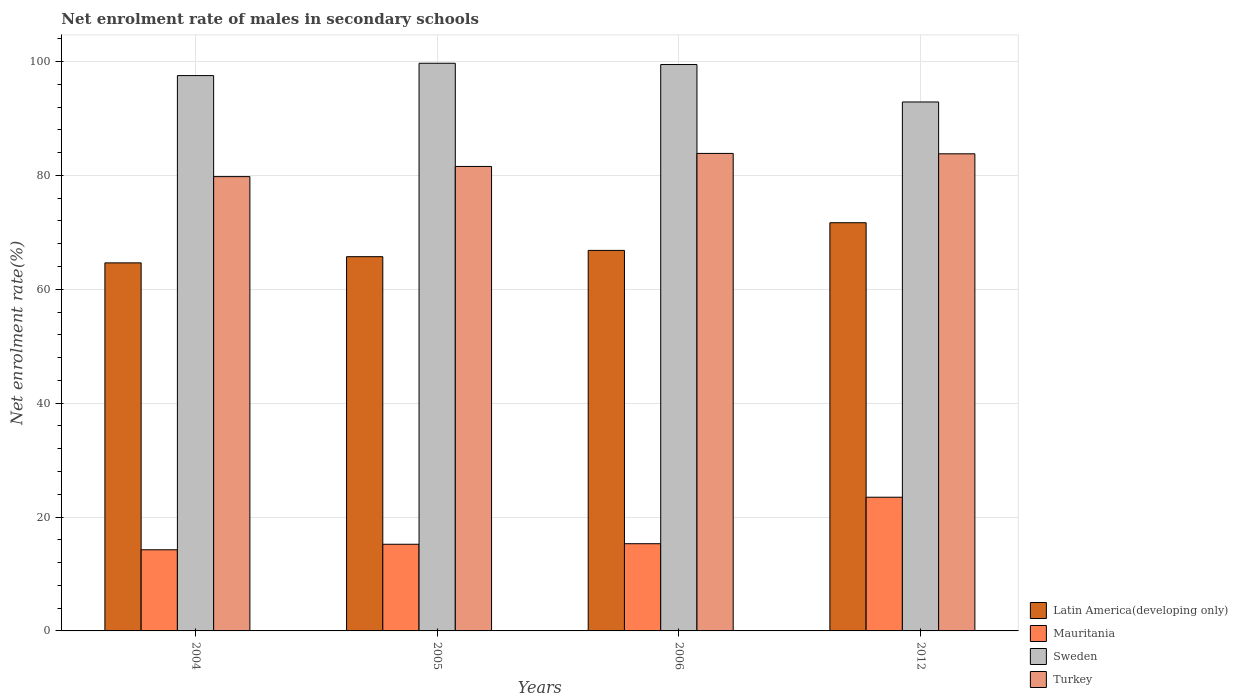Are the number of bars per tick equal to the number of legend labels?
Give a very brief answer. Yes. Are the number of bars on each tick of the X-axis equal?
Keep it short and to the point. Yes. How many bars are there on the 2nd tick from the left?
Your answer should be very brief. 4. How many bars are there on the 3rd tick from the right?
Offer a very short reply. 4. What is the net enrolment rate of males in secondary schools in Latin America(developing only) in 2004?
Make the answer very short. 64.63. Across all years, what is the maximum net enrolment rate of males in secondary schools in Latin America(developing only)?
Provide a succinct answer. 71.68. Across all years, what is the minimum net enrolment rate of males in secondary schools in Sweden?
Provide a short and direct response. 92.88. What is the total net enrolment rate of males in secondary schools in Mauritania in the graph?
Your answer should be very brief. 68.26. What is the difference between the net enrolment rate of males in secondary schools in Turkey in 2004 and that in 2006?
Your answer should be compact. -4.07. What is the difference between the net enrolment rate of males in secondary schools in Mauritania in 2005 and the net enrolment rate of males in secondary schools in Latin America(developing only) in 2004?
Keep it short and to the point. -49.41. What is the average net enrolment rate of males in secondary schools in Turkey per year?
Your response must be concise. 82.24. In the year 2004, what is the difference between the net enrolment rate of males in secondary schools in Turkey and net enrolment rate of males in secondary schools in Latin America(developing only)?
Your answer should be very brief. 15.15. In how many years, is the net enrolment rate of males in secondary schools in Latin America(developing only) greater than 36 %?
Give a very brief answer. 4. What is the ratio of the net enrolment rate of males in secondary schools in Latin America(developing only) in 2006 to that in 2012?
Your answer should be compact. 0.93. Is the net enrolment rate of males in secondary schools in Latin America(developing only) in 2004 less than that in 2012?
Offer a very short reply. Yes. Is the difference between the net enrolment rate of males in secondary schools in Turkey in 2006 and 2012 greater than the difference between the net enrolment rate of males in secondary schools in Latin America(developing only) in 2006 and 2012?
Keep it short and to the point. Yes. What is the difference between the highest and the second highest net enrolment rate of males in secondary schools in Turkey?
Keep it short and to the point. 0.07. What is the difference between the highest and the lowest net enrolment rate of males in secondary schools in Sweden?
Your answer should be very brief. 6.8. In how many years, is the net enrolment rate of males in secondary schools in Sweden greater than the average net enrolment rate of males in secondary schools in Sweden taken over all years?
Your answer should be compact. 3. Is it the case that in every year, the sum of the net enrolment rate of males in secondary schools in Turkey and net enrolment rate of males in secondary schools in Sweden is greater than the sum of net enrolment rate of males in secondary schools in Latin America(developing only) and net enrolment rate of males in secondary schools in Mauritania?
Ensure brevity in your answer.  Yes. What does the 1st bar from the right in 2006 represents?
Give a very brief answer. Turkey. Is it the case that in every year, the sum of the net enrolment rate of males in secondary schools in Turkey and net enrolment rate of males in secondary schools in Latin America(developing only) is greater than the net enrolment rate of males in secondary schools in Sweden?
Your response must be concise. Yes. How many bars are there?
Your answer should be very brief. 16. How many years are there in the graph?
Make the answer very short. 4. Does the graph contain any zero values?
Keep it short and to the point. No. Does the graph contain grids?
Offer a terse response. Yes. How are the legend labels stacked?
Offer a terse response. Vertical. What is the title of the graph?
Keep it short and to the point. Net enrolment rate of males in secondary schools. What is the label or title of the X-axis?
Offer a terse response. Years. What is the label or title of the Y-axis?
Provide a short and direct response. Net enrolment rate(%). What is the Net enrolment rate(%) in Latin America(developing only) in 2004?
Your answer should be compact. 64.63. What is the Net enrolment rate(%) of Mauritania in 2004?
Your response must be concise. 14.25. What is the Net enrolment rate(%) in Sweden in 2004?
Your response must be concise. 97.52. What is the Net enrolment rate(%) of Turkey in 2004?
Offer a terse response. 79.78. What is the Net enrolment rate(%) in Latin America(developing only) in 2005?
Make the answer very short. 65.72. What is the Net enrolment rate(%) in Mauritania in 2005?
Make the answer very short. 15.22. What is the Net enrolment rate(%) in Sweden in 2005?
Make the answer very short. 99.68. What is the Net enrolment rate(%) in Turkey in 2005?
Your response must be concise. 81.56. What is the Net enrolment rate(%) of Latin America(developing only) in 2006?
Give a very brief answer. 66.82. What is the Net enrolment rate(%) in Mauritania in 2006?
Make the answer very short. 15.31. What is the Net enrolment rate(%) in Sweden in 2006?
Keep it short and to the point. 99.46. What is the Net enrolment rate(%) of Turkey in 2006?
Provide a succinct answer. 83.85. What is the Net enrolment rate(%) in Latin America(developing only) in 2012?
Provide a short and direct response. 71.68. What is the Net enrolment rate(%) in Mauritania in 2012?
Provide a succinct answer. 23.48. What is the Net enrolment rate(%) of Sweden in 2012?
Provide a short and direct response. 92.88. What is the Net enrolment rate(%) in Turkey in 2012?
Your answer should be compact. 83.78. Across all years, what is the maximum Net enrolment rate(%) of Latin America(developing only)?
Provide a short and direct response. 71.68. Across all years, what is the maximum Net enrolment rate(%) of Mauritania?
Provide a short and direct response. 23.48. Across all years, what is the maximum Net enrolment rate(%) in Sweden?
Make the answer very short. 99.68. Across all years, what is the maximum Net enrolment rate(%) of Turkey?
Provide a short and direct response. 83.85. Across all years, what is the minimum Net enrolment rate(%) in Latin America(developing only)?
Your answer should be compact. 64.63. Across all years, what is the minimum Net enrolment rate(%) in Mauritania?
Give a very brief answer. 14.25. Across all years, what is the minimum Net enrolment rate(%) of Sweden?
Make the answer very short. 92.88. Across all years, what is the minimum Net enrolment rate(%) of Turkey?
Offer a very short reply. 79.78. What is the total Net enrolment rate(%) of Latin America(developing only) in the graph?
Offer a terse response. 268.85. What is the total Net enrolment rate(%) of Mauritania in the graph?
Make the answer very short. 68.26. What is the total Net enrolment rate(%) in Sweden in the graph?
Offer a terse response. 389.54. What is the total Net enrolment rate(%) of Turkey in the graph?
Make the answer very short. 328.97. What is the difference between the Net enrolment rate(%) of Latin America(developing only) in 2004 and that in 2005?
Provide a short and direct response. -1.09. What is the difference between the Net enrolment rate(%) of Mauritania in 2004 and that in 2005?
Your answer should be compact. -0.97. What is the difference between the Net enrolment rate(%) of Sweden in 2004 and that in 2005?
Your answer should be very brief. -2.16. What is the difference between the Net enrolment rate(%) of Turkey in 2004 and that in 2005?
Give a very brief answer. -1.78. What is the difference between the Net enrolment rate(%) in Latin America(developing only) in 2004 and that in 2006?
Keep it short and to the point. -2.19. What is the difference between the Net enrolment rate(%) of Mauritania in 2004 and that in 2006?
Make the answer very short. -1.07. What is the difference between the Net enrolment rate(%) in Sweden in 2004 and that in 2006?
Your answer should be very brief. -1.94. What is the difference between the Net enrolment rate(%) of Turkey in 2004 and that in 2006?
Offer a very short reply. -4.07. What is the difference between the Net enrolment rate(%) of Latin America(developing only) in 2004 and that in 2012?
Keep it short and to the point. -7.05. What is the difference between the Net enrolment rate(%) of Mauritania in 2004 and that in 2012?
Your answer should be very brief. -9.23. What is the difference between the Net enrolment rate(%) in Sweden in 2004 and that in 2012?
Your response must be concise. 4.63. What is the difference between the Net enrolment rate(%) in Turkey in 2004 and that in 2012?
Your answer should be compact. -4. What is the difference between the Net enrolment rate(%) of Latin America(developing only) in 2005 and that in 2006?
Make the answer very short. -1.1. What is the difference between the Net enrolment rate(%) of Mauritania in 2005 and that in 2006?
Offer a terse response. -0.1. What is the difference between the Net enrolment rate(%) of Sweden in 2005 and that in 2006?
Provide a short and direct response. 0.23. What is the difference between the Net enrolment rate(%) in Turkey in 2005 and that in 2006?
Your answer should be very brief. -2.29. What is the difference between the Net enrolment rate(%) in Latin America(developing only) in 2005 and that in 2012?
Provide a short and direct response. -5.96. What is the difference between the Net enrolment rate(%) in Mauritania in 2005 and that in 2012?
Provide a short and direct response. -8.26. What is the difference between the Net enrolment rate(%) of Sweden in 2005 and that in 2012?
Offer a terse response. 6.8. What is the difference between the Net enrolment rate(%) in Turkey in 2005 and that in 2012?
Give a very brief answer. -2.22. What is the difference between the Net enrolment rate(%) of Latin America(developing only) in 2006 and that in 2012?
Your response must be concise. -4.86. What is the difference between the Net enrolment rate(%) in Mauritania in 2006 and that in 2012?
Provide a succinct answer. -8.16. What is the difference between the Net enrolment rate(%) of Sweden in 2006 and that in 2012?
Your answer should be very brief. 6.57. What is the difference between the Net enrolment rate(%) of Turkey in 2006 and that in 2012?
Give a very brief answer. 0.07. What is the difference between the Net enrolment rate(%) in Latin America(developing only) in 2004 and the Net enrolment rate(%) in Mauritania in 2005?
Your answer should be compact. 49.41. What is the difference between the Net enrolment rate(%) in Latin America(developing only) in 2004 and the Net enrolment rate(%) in Sweden in 2005?
Keep it short and to the point. -35.05. What is the difference between the Net enrolment rate(%) of Latin America(developing only) in 2004 and the Net enrolment rate(%) of Turkey in 2005?
Your answer should be very brief. -16.93. What is the difference between the Net enrolment rate(%) of Mauritania in 2004 and the Net enrolment rate(%) of Sweden in 2005?
Your answer should be very brief. -85.44. What is the difference between the Net enrolment rate(%) in Mauritania in 2004 and the Net enrolment rate(%) in Turkey in 2005?
Your answer should be compact. -67.31. What is the difference between the Net enrolment rate(%) of Sweden in 2004 and the Net enrolment rate(%) of Turkey in 2005?
Provide a succinct answer. 15.96. What is the difference between the Net enrolment rate(%) in Latin America(developing only) in 2004 and the Net enrolment rate(%) in Mauritania in 2006?
Make the answer very short. 49.32. What is the difference between the Net enrolment rate(%) in Latin America(developing only) in 2004 and the Net enrolment rate(%) in Sweden in 2006?
Your answer should be compact. -34.83. What is the difference between the Net enrolment rate(%) of Latin America(developing only) in 2004 and the Net enrolment rate(%) of Turkey in 2006?
Offer a terse response. -19.22. What is the difference between the Net enrolment rate(%) of Mauritania in 2004 and the Net enrolment rate(%) of Sweden in 2006?
Offer a very short reply. -85.21. What is the difference between the Net enrolment rate(%) of Mauritania in 2004 and the Net enrolment rate(%) of Turkey in 2006?
Offer a terse response. -69.6. What is the difference between the Net enrolment rate(%) of Sweden in 2004 and the Net enrolment rate(%) of Turkey in 2006?
Your answer should be compact. 13.67. What is the difference between the Net enrolment rate(%) of Latin America(developing only) in 2004 and the Net enrolment rate(%) of Mauritania in 2012?
Your answer should be compact. 41.15. What is the difference between the Net enrolment rate(%) in Latin America(developing only) in 2004 and the Net enrolment rate(%) in Sweden in 2012?
Provide a short and direct response. -28.25. What is the difference between the Net enrolment rate(%) of Latin America(developing only) in 2004 and the Net enrolment rate(%) of Turkey in 2012?
Ensure brevity in your answer.  -19.15. What is the difference between the Net enrolment rate(%) of Mauritania in 2004 and the Net enrolment rate(%) of Sweden in 2012?
Your answer should be compact. -78.64. What is the difference between the Net enrolment rate(%) of Mauritania in 2004 and the Net enrolment rate(%) of Turkey in 2012?
Offer a terse response. -69.54. What is the difference between the Net enrolment rate(%) of Sweden in 2004 and the Net enrolment rate(%) of Turkey in 2012?
Your response must be concise. 13.74. What is the difference between the Net enrolment rate(%) of Latin America(developing only) in 2005 and the Net enrolment rate(%) of Mauritania in 2006?
Your answer should be compact. 50.4. What is the difference between the Net enrolment rate(%) in Latin America(developing only) in 2005 and the Net enrolment rate(%) in Sweden in 2006?
Make the answer very short. -33.74. What is the difference between the Net enrolment rate(%) in Latin America(developing only) in 2005 and the Net enrolment rate(%) in Turkey in 2006?
Your response must be concise. -18.13. What is the difference between the Net enrolment rate(%) of Mauritania in 2005 and the Net enrolment rate(%) of Sweden in 2006?
Your answer should be very brief. -84.24. What is the difference between the Net enrolment rate(%) in Mauritania in 2005 and the Net enrolment rate(%) in Turkey in 2006?
Make the answer very short. -68.63. What is the difference between the Net enrolment rate(%) in Sweden in 2005 and the Net enrolment rate(%) in Turkey in 2006?
Provide a short and direct response. 15.83. What is the difference between the Net enrolment rate(%) in Latin America(developing only) in 2005 and the Net enrolment rate(%) in Mauritania in 2012?
Your answer should be very brief. 42.24. What is the difference between the Net enrolment rate(%) of Latin America(developing only) in 2005 and the Net enrolment rate(%) of Sweden in 2012?
Provide a succinct answer. -27.17. What is the difference between the Net enrolment rate(%) of Latin America(developing only) in 2005 and the Net enrolment rate(%) of Turkey in 2012?
Give a very brief answer. -18.06. What is the difference between the Net enrolment rate(%) in Mauritania in 2005 and the Net enrolment rate(%) in Sweden in 2012?
Your answer should be very brief. -77.66. What is the difference between the Net enrolment rate(%) in Mauritania in 2005 and the Net enrolment rate(%) in Turkey in 2012?
Your answer should be compact. -68.56. What is the difference between the Net enrolment rate(%) of Sweden in 2005 and the Net enrolment rate(%) of Turkey in 2012?
Keep it short and to the point. 15.9. What is the difference between the Net enrolment rate(%) of Latin America(developing only) in 2006 and the Net enrolment rate(%) of Mauritania in 2012?
Keep it short and to the point. 43.34. What is the difference between the Net enrolment rate(%) of Latin America(developing only) in 2006 and the Net enrolment rate(%) of Sweden in 2012?
Keep it short and to the point. -26.06. What is the difference between the Net enrolment rate(%) of Latin America(developing only) in 2006 and the Net enrolment rate(%) of Turkey in 2012?
Provide a short and direct response. -16.96. What is the difference between the Net enrolment rate(%) of Mauritania in 2006 and the Net enrolment rate(%) of Sweden in 2012?
Ensure brevity in your answer.  -77.57. What is the difference between the Net enrolment rate(%) in Mauritania in 2006 and the Net enrolment rate(%) in Turkey in 2012?
Your answer should be compact. -68.47. What is the difference between the Net enrolment rate(%) of Sweden in 2006 and the Net enrolment rate(%) of Turkey in 2012?
Offer a very short reply. 15.67. What is the average Net enrolment rate(%) in Latin America(developing only) per year?
Your answer should be very brief. 67.21. What is the average Net enrolment rate(%) in Mauritania per year?
Give a very brief answer. 17.06. What is the average Net enrolment rate(%) in Sweden per year?
Offer a terse response. 97.38. What is the average Net enrolment rate(%) of Turkey per year?
Provide a short and direct response. 82.24. In the year 2004, what is the difference between the Net enrolment rate(%) of Latin America(developing only) and Net enrolment rate(%) of Mauritania?
Ensure brevity in your answer.  50.38. In the year 2004, what is the difference between the Net enrolment rate(%) of Latin America(developing only) and Net enrolment rate(%) of Sweden?
Offer a very short reply. -32.89. In the year 2004, what is the difference between the Net enrolment rate(%) in Latin America(developing only) and Net enrolment rate(%) in Turkey?
Your answer should be very brief. -15.15. In the year 2004, what is the difference between the Net enrolment rate(%) of Mauritania and Net enrolment rate(%) of Sweden?
Your answer should be compact. -83.27. In the year 2004, what is the difference between the Net enrolment rate(%) in Mauritania and Net enrolment rate(%) in Turkey?
Your answer should be compact. -65.53. In the year 2004, what is the difference between the Net enrolment rate(%) of Sweden and Net enrolment rate(%) of Turkey?
Make the answer very short. 17.74. In the year 2005, what is the difference between the Net enrolment rate(%) of Latin America(developing only) and Net enrolment rate(%) of Mauritania?
Make the answer very short. 50.5. In the year 2005, what is the difference between the Net enrolment rate(%) in Latin America(developing only) and Net enrolment rate(%) in Sweden?
Provide a succinct answer. -33.96. In the year 2005, what is the difference between the Net enrolment rate(%) in Latin America(developing only) and Net enrolment rate(%) in Turkey?
Your response must be concise. -15.84. In the year 2005, what is the difference between the Net enrolment rate(%) in Mauritania and Net enrolment rate(%) in Sweden?
Your response must be concise. -84.46. In the year 2005, what is the difference between the Net enrolment rate(%) in Mauritania and Net enrolment rate(%) in Turkey?
Provide a succinct answer. -66.34. In the year 2005, what is the difference between the Net enrolment rate(%) of Sweden and Net enrolment rate(%) of Turkey?
Keep it short and to the point. 18.12. In the year 2006, what is the difference between the Net enrolment rate(%) in Latin America(developing only) and Net enrolment rate(%) in Mauritania?
Ensure brevity in your answer.  51.5. In the year 2006, what is the difference between the Net enrolment rate(%) of Latin America(developing only) and Net enrolment rate(%) of Sweden?
Your answer should be compact. -32.64. In the year 2006, what is the difference between the Net enrolment rate(%) in Latin America(developing only) and Net enrolment rate(%) in Turkey?
Offer a very short reply. -17.03. In the year 2006, what is the difference between the Net enrolment rate(%) of Mauritania and Net enrolment rate(%) of Sweden?
Provide a short and direct response. -84.14. In the year 2006, what is the difference between the Net enrolment rate(%) of Mauritania and Net enrolment rate(%) of Turkey?
Your answer should be compact. -68.54. In the year 2006, what is the difference between the Net enrolment rate(%) of Sweden and Net enrolment rate(%) of Turkey?
Your answer should be compact. 15.6. In the year 2012, what is the difference between the Net enrolment rate(%) of Latin America(developing only) and Net enrolment rate(%) of Mauritania?
Offer a terse response. 48.2. In the year 2012, what is the difference between the Net enrolment rate(%) in Latin America(developing only) and Net enrolment rate(%) in Sweden?
Offer a terse response. -21.21. In the year 2012, what is the difference between the Net enrolment rate(%) of Latin America(developing only) and Net enrolment rate(%) of Turkey?
Your answer should be compact. -12.1. In the year 2012, what is the difference between the Net enrolment rate(%) in Mauritania and Net enrolment rate(%) in Sweden?
Offer a very short reply. -69.41. In the year 2012, what is the difference between the Net enrolment rate(%) in Mauritania and Net enrolment rate(%) in Turkey?
Your response must be concise. -60.31. In the year 2012, what is the difference between the Net enrolment rate(%) in Sweden and Net enrolment rate(%) in Turkey?
Offer a very short reply. 9.1. What is the ratio of the Net enrolment rate(%) in Latin America(developing only) in 2004 to that in 2005?
Your answer should be very brief. 0.98. What is the ratio of the Net enrolment rate(%) of Mauritania in 2004 to that in 2005?
Make the answer very short. 0.94. What is the ratio of the Net enrolment rate(%) in Sweden in 2004 to that in 2005?
Keep it short and to the point. 0.98. What is the ratio of the Net enrolment rate(%) in Turkey in 2004 to that in 2005?
Offer a very short reply. 0.98. What is the ratio of the Net enrolment rate(%) in Latin America(developing only) in 2004 to that in 2006?
Make the answer very short. 0.97. What is the ratio of the Net enrolment rate(%) in Mauritania in 2004 to that in 2006?
Keep it short and to the point. 0.93. What is the ratio of the Net enrolment rate(%) of Sweden in 2004 to that in 2006?
Give a very brief answer. 0.98. What is the ratio of the Net enrolment rate(%) in Turkey in 2004 to that in 2006?
Keep it short and to the point. 0.95. What is the ratio of the Net enrolment rate(%) in Latin America(developing only) in 2004 to that in 2012?
Make the answer very short. 0.9. What is the ratio of the Net enrolment rate(%) of Mauritania in 2004 to that in 2012?
Keep it short and to the point. 0.61. What is the ratio of the Net enrolment rate(%) of Sweden in 2004 to that in 2012?
Offer a terse response. 1.05. What is the ratio of the Net enrolment rate(%) of Turkey in 2004 to that in 2012?
Your answer should be compact. 0.95. What is the ratio of the Net enrolment rate(%) in Latin America(developing only) in 2005 to that in 2006?
Give a very brief answer. 0.98. What is the ratio of the Net enrolment rate(%) in Turkey in 2005 to that in 2006?
Your response must be concise. 0.97. What is the ratio of the Net enrolment rate(%) in Latin America(developing only) in 2005 to that in 2012?
Keep it short and to the point. 0.92. What is the ratio of the Net enrolment rate(%) of Mauritania in 2005 to that in 2012?
Offer a terse response. 0.65. What is the ratio of the Net enrolment rate(%) in Sweden in 2005 to that in 2012?
Your answer should be very brief. 1.07. What is the ratio of the Net enrolment rate(%) of Turkey in 2005 to that in 2012?
Your answer should be compact. 0.97. What is the ratio of the Net enrolment rate(%) in Latin America(developing only) in 2006 to that in 2012?
Offer a very short reply. 0.93. What is the ratio of the Net enrolment rate(%) in Mauritania in 2006 to that in 2012?
Your response must be concise. 0.65. What is the ratio of the Net enrolment rate(%) in Sweden in 2006 to that in 2012?
Offer a very short reply. 1.07. What is the difference between the highest and the second highest Net enrolment rate(%) of Latin America(developing only)?
Ensure brevity in your answer.  4.86. What is the difference between the highest and the second highest Net enrolment rate(%) of Mauritania?
Provide a succinct answer. 8.16. What is the difference between the highest and the second highest Net enrolment rate(%) in Sweden?
Keep it short and to the point. 0.23. What is the difference between the highest and the second highest Net enrolment rate(%) in Turkey?
Ensure brevity in your answer.  0.07. What is the difference between the highest and the lowest Net enrolment rate(%) of Latin America(developing only)?
Offer a very short reply. 7.05. What is the difference between the highest and the lowest Net enrolment rate(%) of Mauritania?
Ensure brevity in your answer.  9.23. What is the difference between the highest and the lowest Net enrolment rate(%) in Sweden?
Provide a succinct answer. 6.8. What is the difference between the highest and the lowest Net enrolment rate(%) of Turkey?
Offer a terse response. 4.07. 